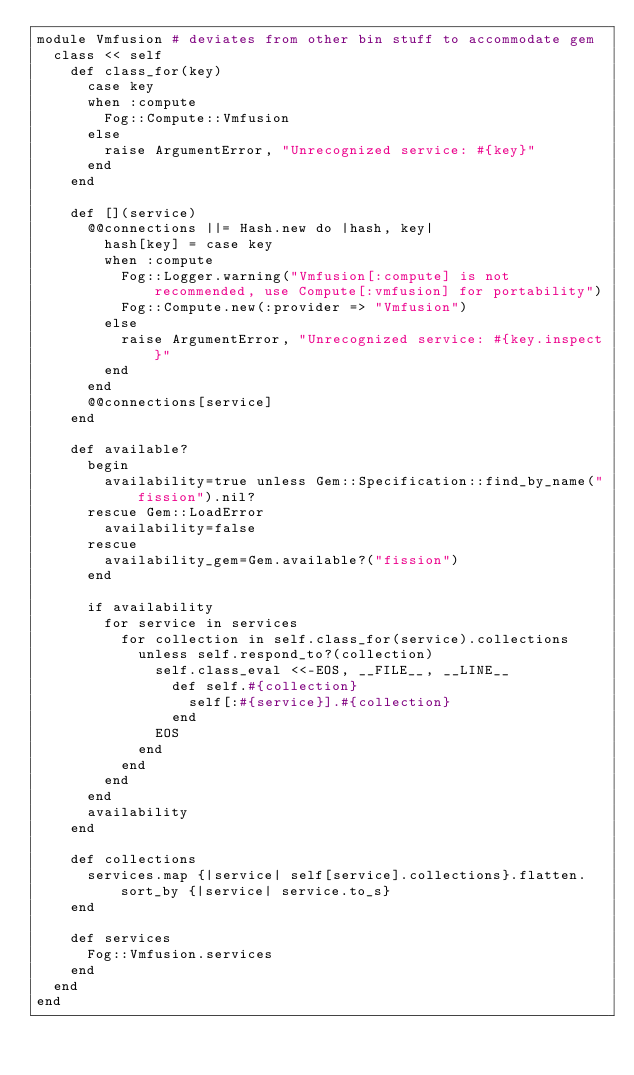<code> <loc_0><loc_0><loc_500><loc_500><_Ruby_>module Vmfusion # deviates from other bin stuff to accommodate gem
  class << self
    def class_for(key)
      case key
      when :compute
        Fog::Compute::Vmfusion
      else
        raise ArgumentError, "Unrecognized service: #{key}"
      end
    end

    def [](service)
      @@connections ||= Hash.new do |hash, key|
        hash[key] = case key
        when :compute
          Fog::Logger.warning("Vmfusion[:compute] is not recommended, use Compute[:vmfusion] for portability")
          Fog::Compute.new(:provider => "Vmfusion")
        else
          raise ArgumentError, "Unrecognized service: #{key.inspect}"
        end
      end
      @@connections[service]
    end

    def available?
      begin
        availability=true unless Gem::Specification::find_by_name("fission").nil?
      rescue Gem::LoadError
        availability=false
      rescue
        availability_gem=Gem.available?("fission")
      end

      if availability
        for service in services
          for collection in self.class_for(service).collections
            unless self.respond_to?(collection)
              self.class_eval <<-EOS, __FILE__, __LINE__
                def self.#{collection}
                  self[:#{service}].#{collection}
                end
              EOS
            end
          end
        end
      end
      availability
    end

    def collections
      services.map {|service| self[service].collections}.flatten.sort_by {|service| service.to_s}
    end

    def services
      Fog::Vmfusion.services
    end
  end
end
</code> 